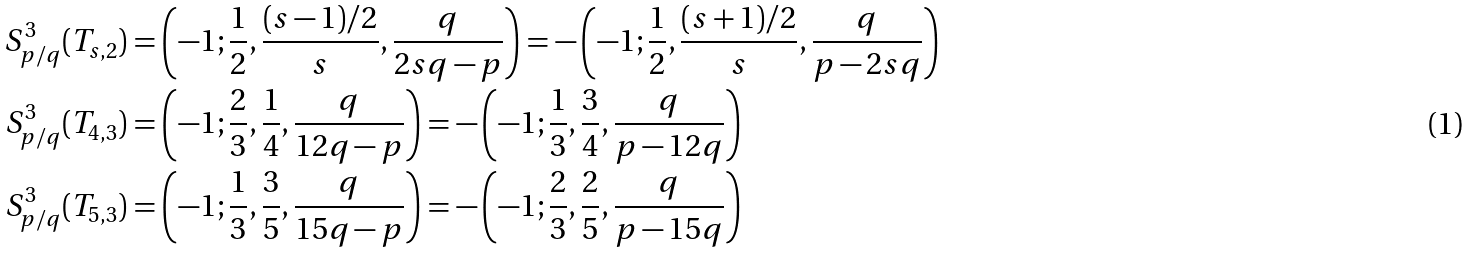<formula> <loc_0><loc_0><loc_500><loc_500>S ^ { 3 } _ { p / q } ( T _ { s , 2 } ) & = \left ( - 1 ; \frac { 1 } { 2 } , \frac { ( s - 1 ) / 2 } { s } , \frac { q } { 2 s q - p } \right ) = - \left ( - 1 ; \frac { 1 } { 2 } , \frac { ( s + 1 ) / 2 } { s } , \frac { q } { p - 2 s q } \right ) \\ S ^ { 3 } _ { p / q } ( T _ { 4 , 3 } ) & = \left ( - 1 ; \frac { 2 } { 3 } , \frac { 1 } { 4 } , \frac { q } { 1 2 q - p } \right ) = - \left ( - 1 ; \frac { 1 } { 3 } , \frac { 3 } { 4 } , \frac { q } { p - 1 2 q } \right ) \\ S ^ { 3 } _ { p / q } ( T _ { 5 , 3 } ) & = \left ( - 1 ; \frac { 1 } { 3 } , \frac { 3 } { 5 } , \frac { q } { 1 5 q - p } \right ) = - \left ( - 1 ; \frac { 2 } { 3 } , \frac { 2 } { 5 } , \frac { q } { p - 1 5 q } \right )</formula> 